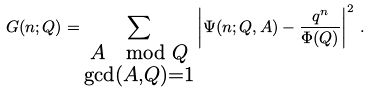<formula> <loc_0><loc_0><loc_500><loc_500>G ( n ; Q ) = \sum _ { \substack { A \mod Q \\ \gcd ( A , Q ) = 1 } } \left | \Psi ( n ; Q , A ) - \frac { q ^ { n } } { \Phi ( Q ) } \right | ^ { 2 } \, .</formula> 